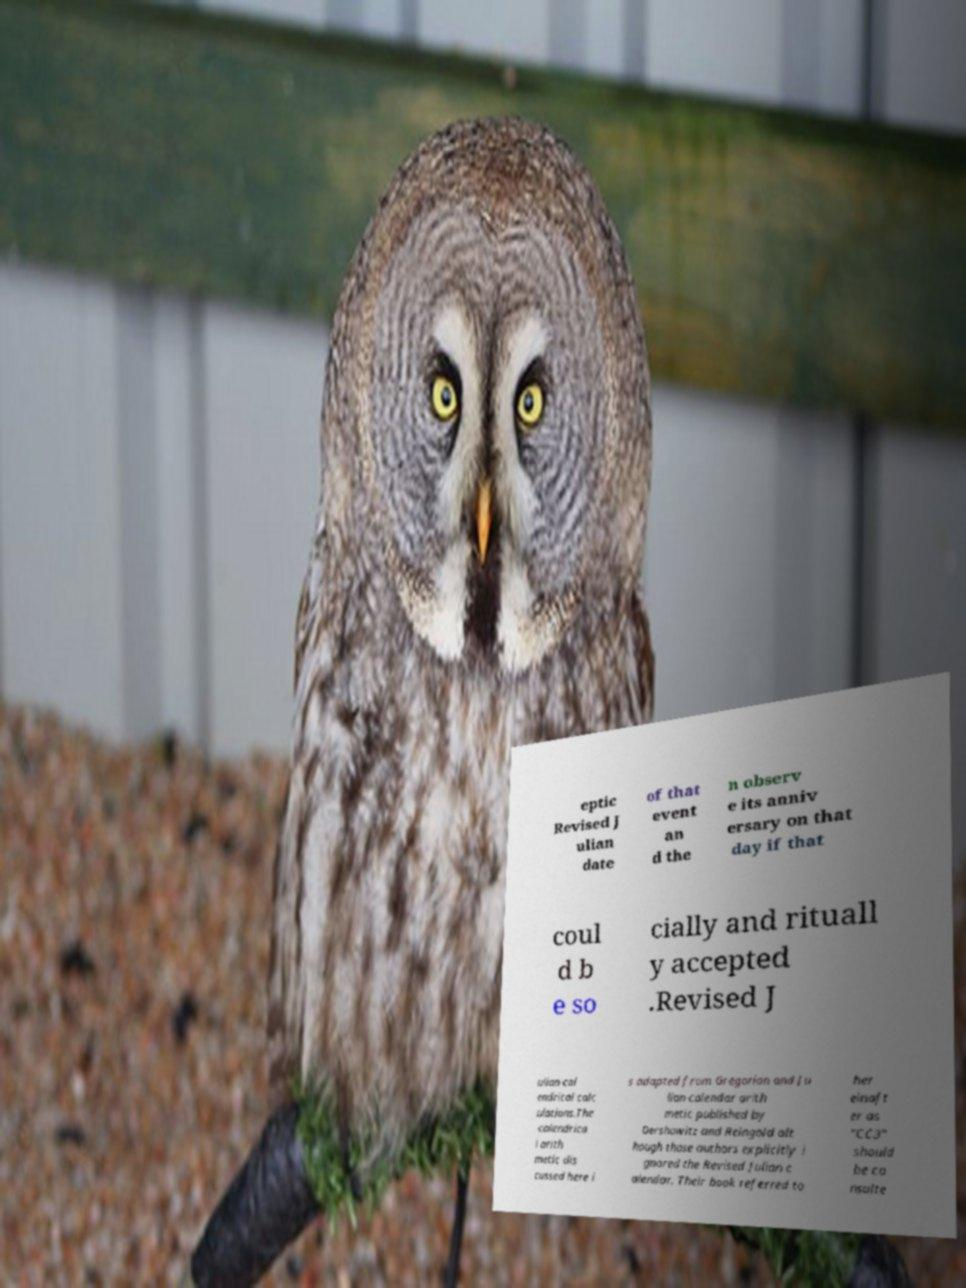I need the written content from this picture converted into text. Can you do that? eptic Revised J ulian date of that event an d the n observ e its anniv ersary on that day if that coul d b e so cially and rituall y accepted .Revised J ulian cal endrical calc ulations.The calendrica l arith metic dis cussed here i s adapted from Gregorian and Ju lian calendar arith metic published by Dershowitz and Reingold alt hough those authors explicitly i gnored the Revised Julian c alendar. Their book referred to her einaft er as "CC3" should be co nsulte 